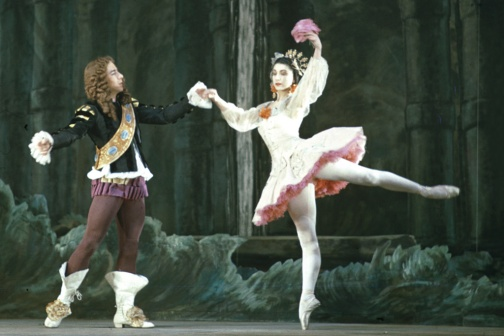Imagine if this performance was set in a different era or place; how would the costumes and setting change? Picture this sharegpt4v/same performance set in ancient Greece. The rocky cave-like stage would transform into the marble pillars and lush gardens of an Athenian courtyard. The male dancer, instead of a royal blue and gold jacket, might wear a flowing white chiton with golden laurel accents and sandals. The female dancer would trade her tutu for a similarly flowing peplos or a delicate, light tunic, adorned with intricate Greek patterns. Their dance, anchored in the mythologies and philosophies of ancient Greece, would take on a new narrative richness, filled with stories of gods, heroes, and mythical creatures. 